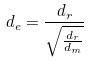Convert formula to latex. <formula><loc_0><loc_0><loc_500><loc_500>d _ { e } = \frac { d _ { r } } { \sqrt { \frac { d _ { r } } { d _ { m } } } }</formula> 